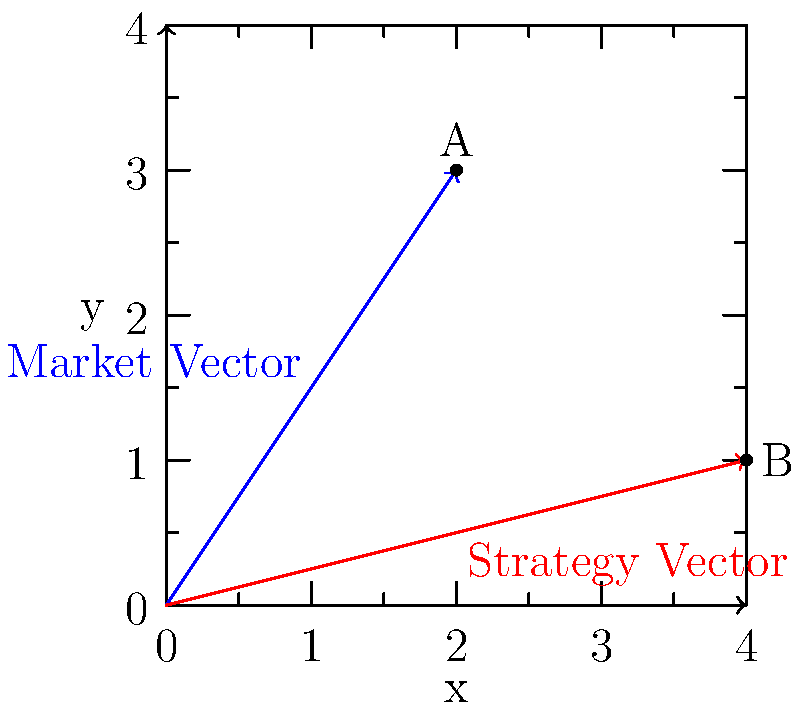As a savvy entrepreneur, you're evaluating the alignment of your business strategy with current market trends. The market trend is represented by vector $\vec{a} = (2, 3)$, and your business strategy is represented by vector $\vec{b} = (4, 1)$. Calculate the cosine of the angle between these two vectors to determine how well your strategy aligns with the market. Round your answer to two decimal places. To solve this problem, we'll use the dot product formula and the relationship between dot product and the cosine of the angle between two vectors. Let's proceed step-by-step:

1) The formula for the cosine of the angle between two vectors is:

   $$\cos \theta = \frac{\vec{a} \cdot \vec{b}}{|\vec{a}||\vec{b}|}$$

2) First, let's calculate the dot product $\vec{a} \cdot \vec{b}$:
   $$\vec{a} \cdot \vec{b} = (2)(4) + (3)(1) = 8 + 3 = 11$$

3) Now, we need to calculate the magnitudes of $\vec{a}$ and $\vec{b}$:
   $$|\vec{a}| = \sqrt{2^2 + 3^2} = \sqrt{4 + 9} = \sqrt{13}$$
   $$|\vec{b}| = \sqrt{4^2 + 1^2} = \sqrt{16 + 1} = \sqrt{17}$$

4) Substituting these values into our formula:

   $$\cos \theta = \frac{11}{\sqrt{13}\sqrt{17}}$$

5) Simplify:
   $$\cos \theta = \frac{11}{\sqrt{221}} \approx 0.7400$$

6) Rounding to two decimal places:
   $$\cos \theta \approx 0.74$$

This result indicates a relatively strong alignment between your strategy and the market trend, as a cosine of 1 would indicate perfect alignment and 0 would indicate perpendicular (no) alignment.
Answer: 0.74 